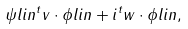<formula> <loc_0><loc_0><loc_500><loc_500>\psi l i n ^ { t } v \cdot { \phi l i n } + i ^ { t } w \cdot { \phi l i n } ,</formula> 